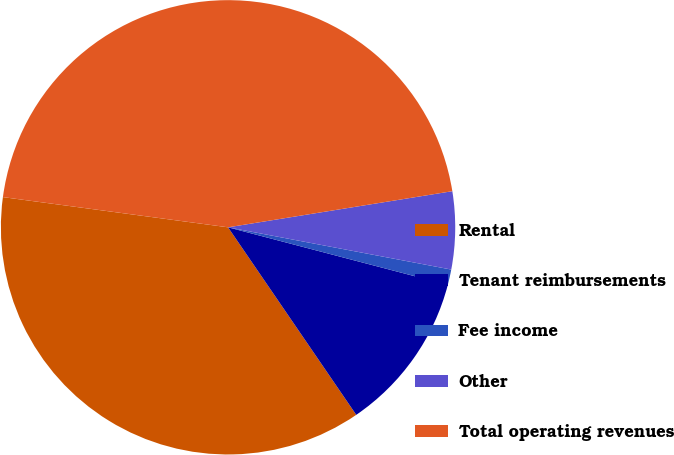Convert chart to OTSL. <chart><loc_0><loc_0><loc_500><loc_500><pie_chart><fcel>Rental<fcel>Tenant reimbursements<fcel>Fee income<fcel>Other<fcel>Total operating revenues<nl><fcel>36.67%<fcel>11.38%<fcel>1.1%<fcel>5.52%<fcel>45.34%<nl></chart> 